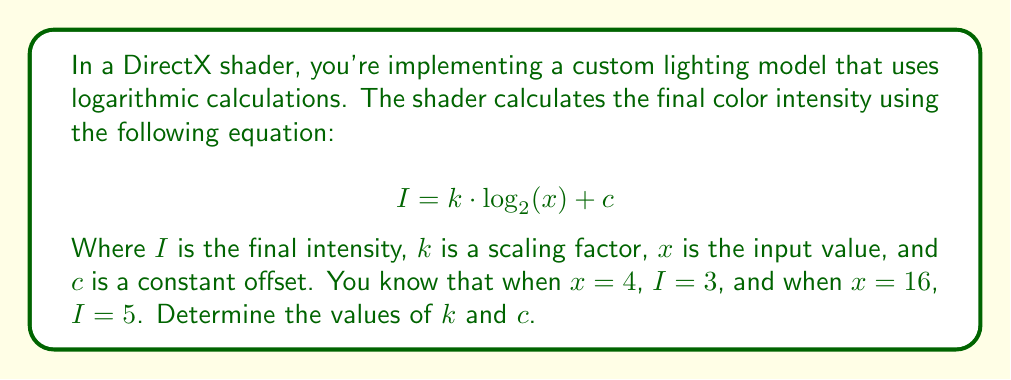Can you solve this math problem? To solve this problem, we'll use the given information to create a system of equations and then solve for the unknown variables $k$ and $c$.

1) First, let's write out our two equations using the given information:

   When $x = 4$, $I = 3$:
   $$ 3 = k \cdot \log_2(4) + c $$

   When $x = 16$, $I = 5$:
   $$ 5 = k \cdot \log_2(16) + c $$

2) Simplify the logarithms:
   $$ 3 = k \cdot 2 + c $$
   $$ 5 = k \cdot 4 + c $$

3) Now we have a system of two equations with two unknowns:
   $$ 3 = 2k + c $$
   $$ 5 = 4k + c $$

4) Subtract the first equation from the second:
   $$ 2 = 2k $$

5) Solve for $k$:
   $$ k = 1 $$

6) Substitute $k = 1$ into either of the original equations to solve for $c$:
   Using $3 = 2k + c$:
   $$ 3 = 2(1) + c $$
   $$ 3 = 2 + c $$
   $$ c = 1 $$

7) Verify the solution using the second equation:
   $$ 5 = 4(1) + 1 $$
   $$ 5 = 5 $$ (This checks out)

Therefore, the values of $k$ and $c$ are 1 and 1, respectively.
Answer: $k = 1$, $c = 1$ 